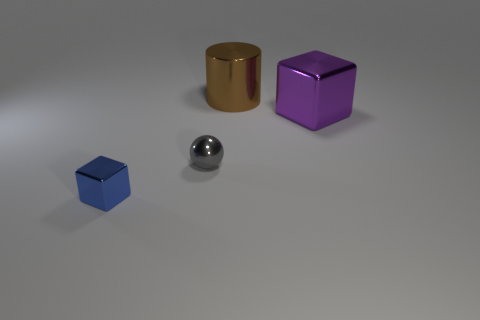Add 4 tiny cyan rubber balls. How many objects exist? 8 Add 1 big cubes. How many big cubes exist? 2 Subtract all purple blocks. How many blocks are left? 1 Subtract 0 yellow cubes. How many objects are left? 4 Subtract 1 cylinders. How many cylinders are left? 0 Subtract all red spheres. Subtract all green cubes. How many spheres are left? 1 Subtract all gray spheres. How many gray blocks are left? 0 Subtract all tiny red metal blocks. Subtract all purple metal things. How many objects are left? 3 Add 4 big brown objects. How many big brown objects are left? 5 